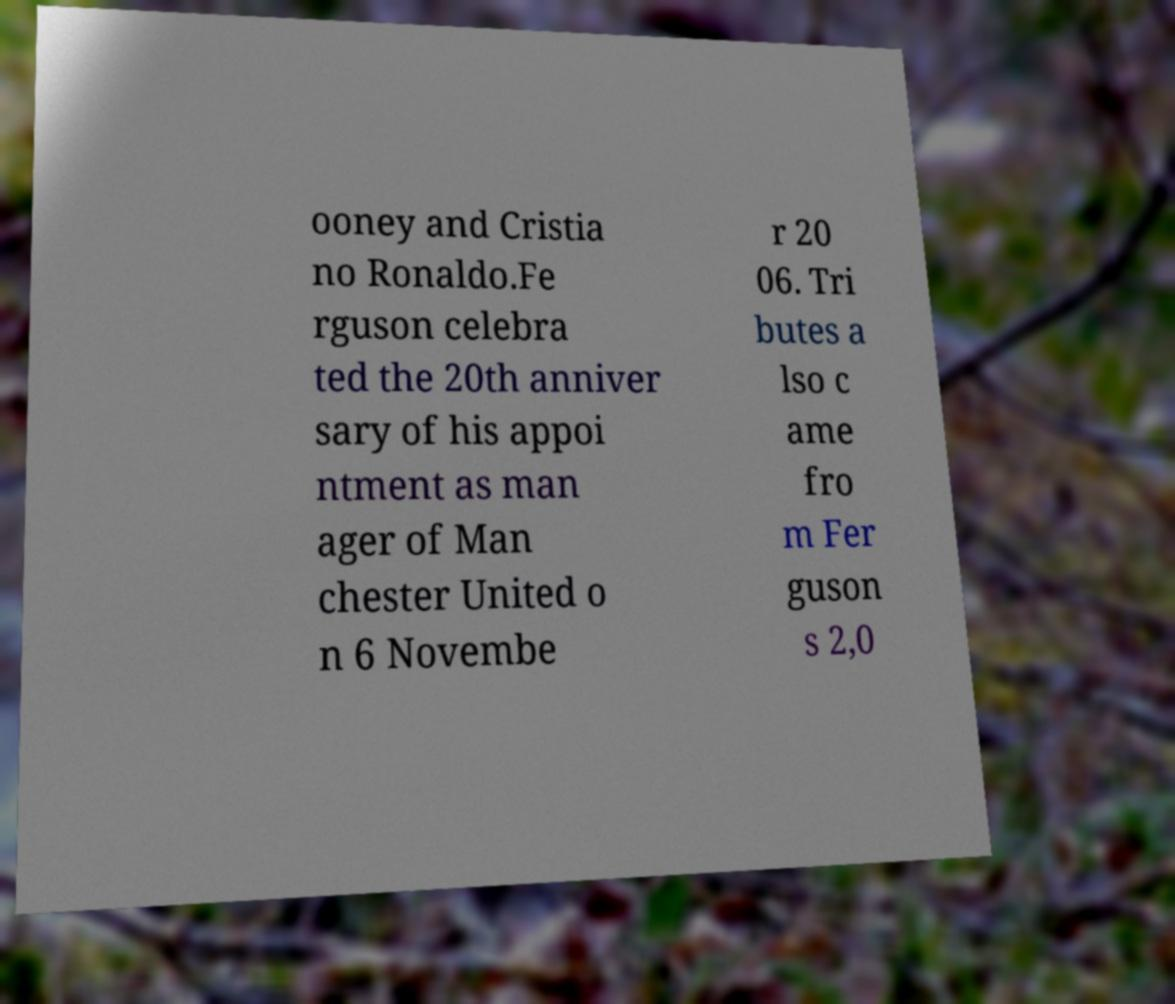Can you accurately transcribe the text from the provided image for me? ooney and Cristia no Ronaldo.Fe rguson celebra ted the 20th anniver sary of his appoi ntment as man ager of Man chester United o n 6 Novembe r 20 06. Tri butes a lso c ame fro m Fer guson s 2,0 